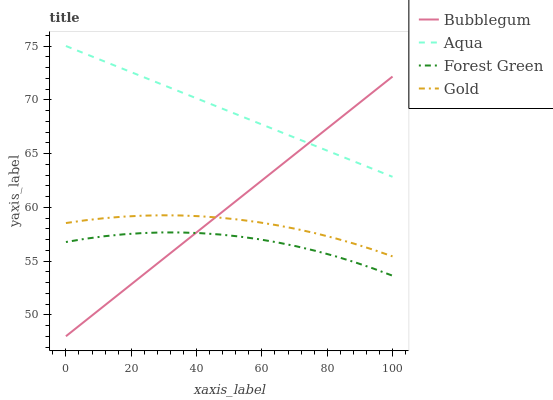Does Forest Green have the minimum area under the curve?
Answer yes or no. Yes. Does Aqua have the maximum area under the curve?
Answer yes or no. Yes. Does Gold have the minimum area under the curve?
Answer yes or no. No. Does Gold have the maximum area under the curve?
Answer yes or no. No. Is Bubblegum the smoothest?
Answer yes or no. Yes. Is Forest Green the roughest?
Answer yes or no. Yes. Is Aqua the smoothest?
Answer yes or no. No. Is Aqua the roughest?
Answer yes or no. No. Does Gold have the lowest value?
Answer yes or no. No. Does Aqua have the highest value?
Answer yes or no. Yes. Does Gold have the highest value?
Answer yes or no. No. Is Forest Green less than Aqua?
Answer yes or no. Yes. Is Aqua greater than Forest Green?
Answer yes or no. Yes. Does Aqua intersect Bubblegum?
Answer yes or no. Yes. Is Aqua less than Bubblegum?
Answer yes or no. No. Is Aqua greater than Bubblegum?
Answer yes or no. No. Does Forest Green intersect Aqua?
Answer yes or no. No. 